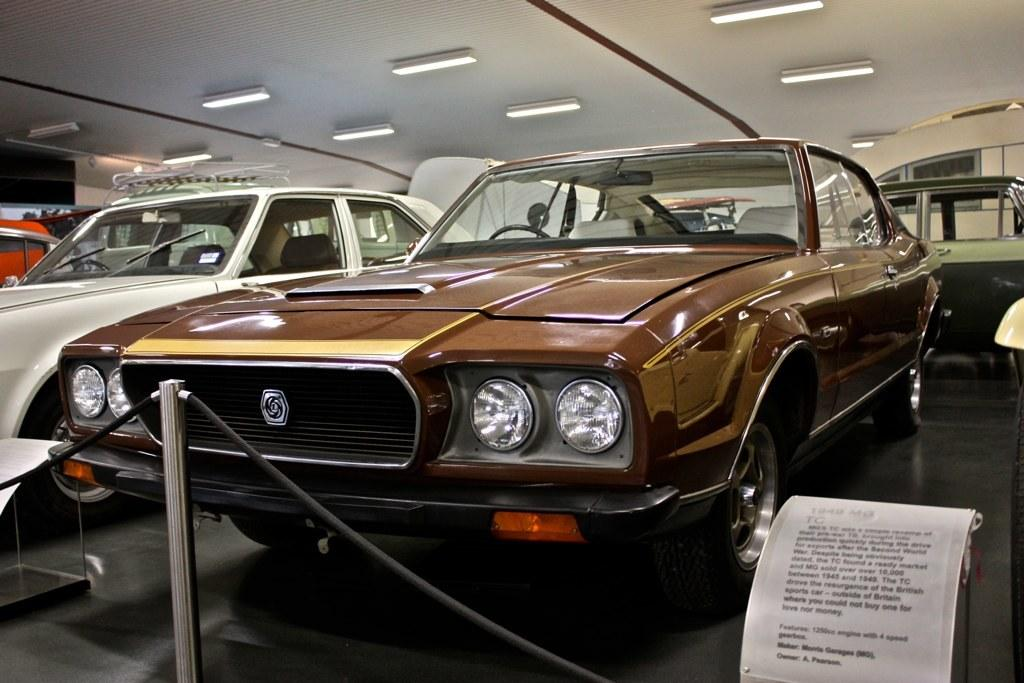What objects are on the floor in the image? There are cars on the floor in the image. What vertical structure can be seen in the image? There is a pole in the image. What type of flexible material is present in the image? There are ropes in the image. What can be used to provide information or directions in the image? There is an information board in the image. What unspecified object is present in the image? There is an object in the image. What part of the room can be seen in the background of the image? The ceiling is visible in the background of the image. What illuminating devices are present in the background of the image? Lights are present in the background of the image. What type of fruit is hanging from the pole in the image? There is no fruit hanging from the pole in the image; it is a pole with ropes and other objects. What type of button can be seen on the cars in the image? There is no button visible on the cars in the image; they are toy cars without any buttons. 